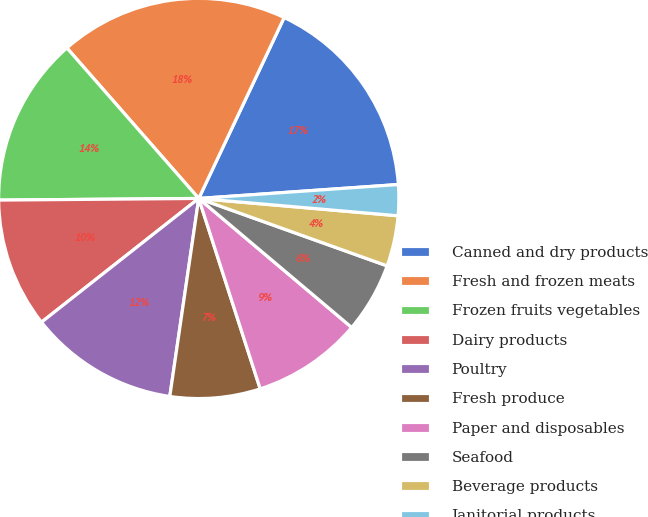Convert chart. <chart><loc_0><loc_0><loc_500><loc_500><pie_chart><fcel>Canned and dry products<fcel>Fresh and frozen meats<fcel>Frozen fruits vegetables<fcel>Dairy products<fcel>Poultry<fcel>Fresh produce<fcel>Paper and disposables<fcel>Seafood<fcel>Beverage products<fcel>Janitorial products<nl><fcel>16.87%<fcel>18.47%<fcel>13.68%<fcel>10.48%<fcel>12.08%<fcel>7.28%<fcel>8.88%<fcel>5.68%<fcel>4.09%<fcel>2.49%<nl></chart> 